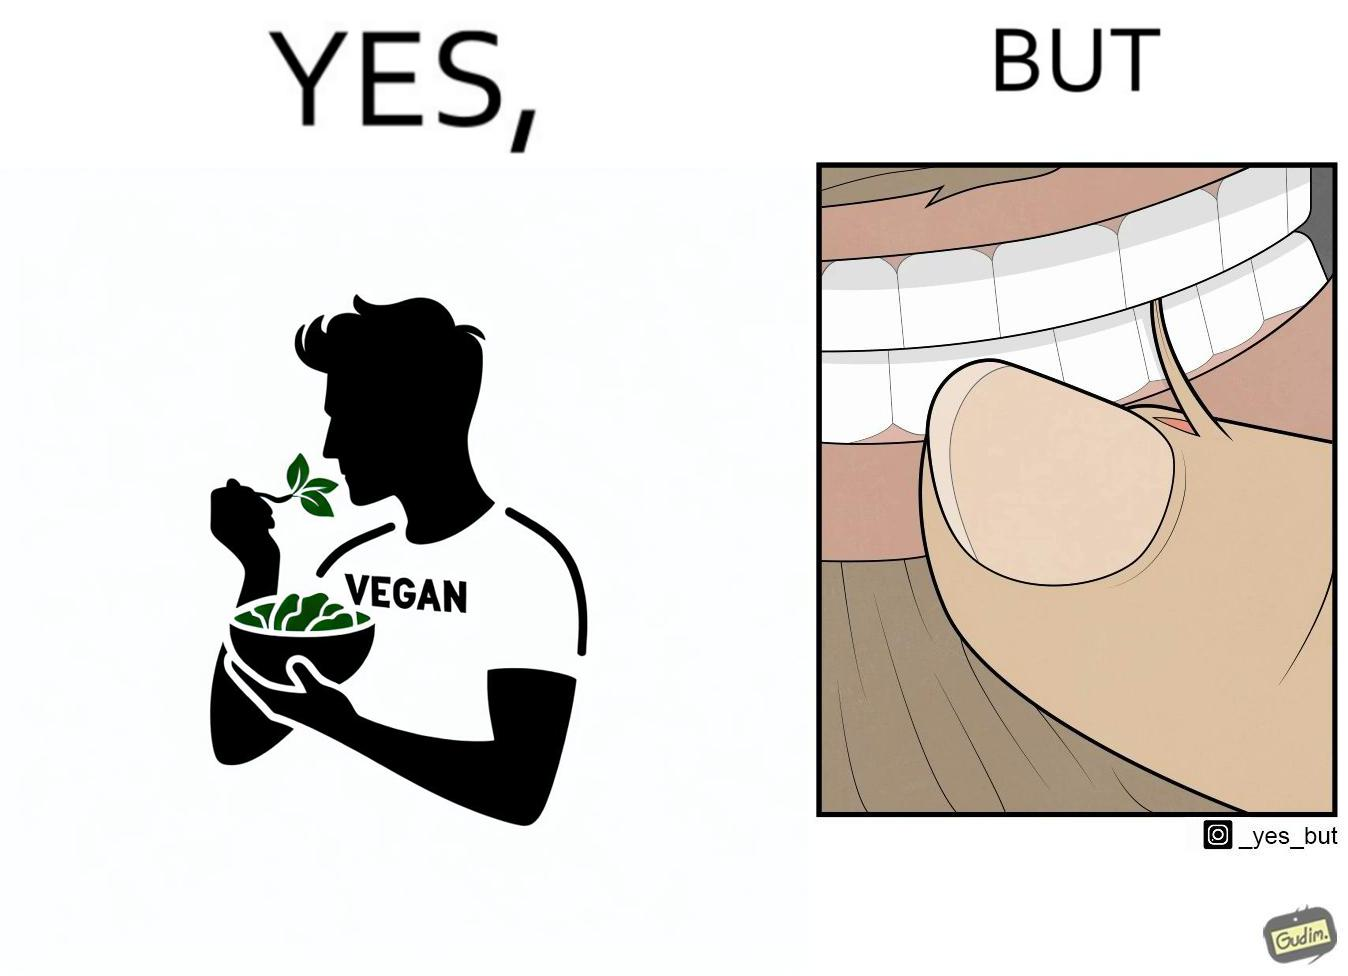What does this image depict? The image is funny because while the man claims to be vegan, he is biting skin off his own hand. 